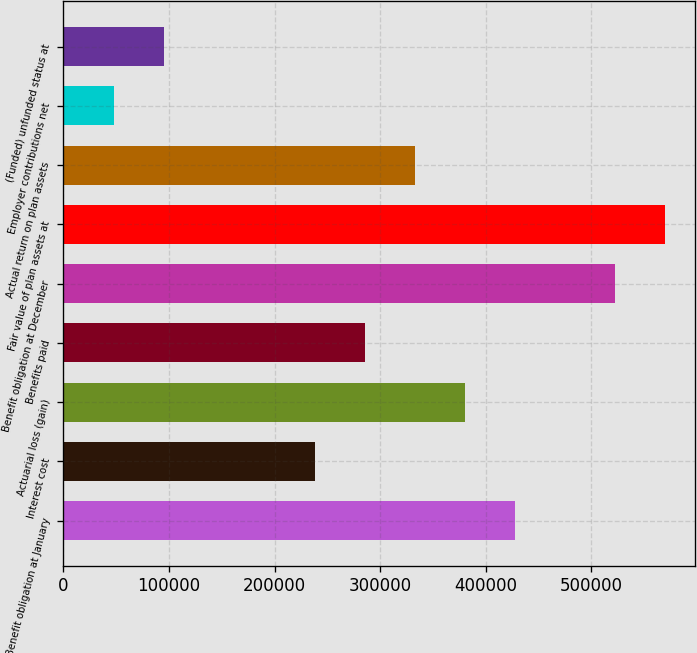Convert chart to OTSL. <chart><loc_0><loc_0><loc_500><loc_500><bar_chart><fcel>Benefit obligation at January<fcel>Interest cost<fcel>Actuarial loss (gain)<fcel>Benefits paid<fcel>Benefit obligation at December<fcel>Fair value of plan assets at<fcel>Actual return on plan assets<fcel>Employer contributions net<fcel>(Funded) unfunded status at<nl><fcel>427829<fcel>238022<fcel>380377<fcel>285473<fcel>522733<fcel>570185<fcel>332925<fcel>48213.9<fcel>95665.8<nl></chart> 